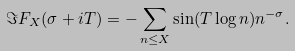Convert formula to latex. <formula><loc_0><loc_0><loc_500><loc_500>\Im F _ { X } ( \sigma + i T ) = - \sum _ { n \leq X } \sin ( T \log n ) n ^ { - \sigma } .</formula> 